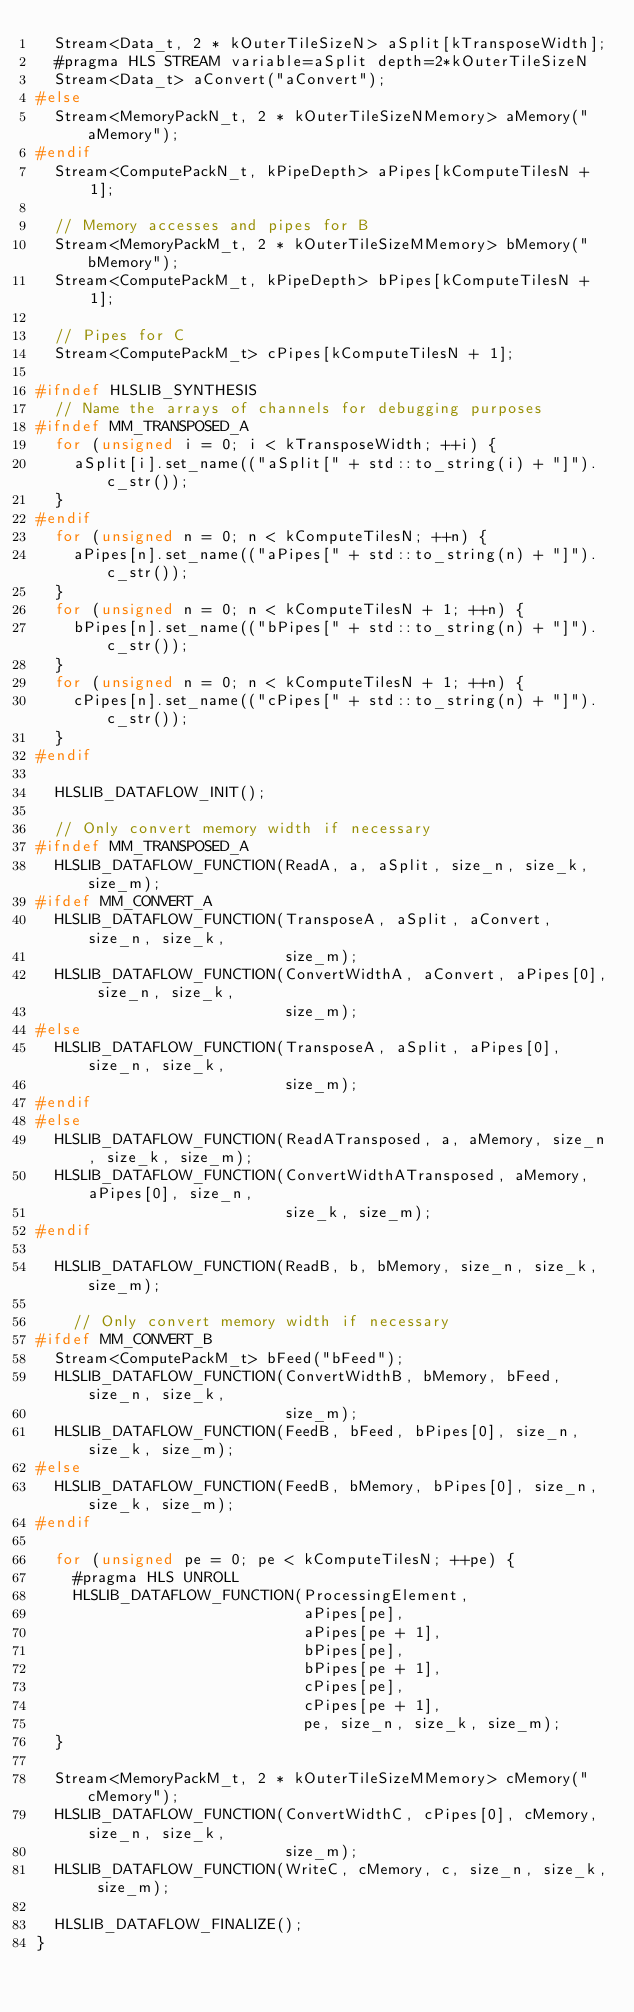Convert code to text. <code><loc_0><loc_0><loc_500><loc_500><_C++_>  Stream<Data_t, 2 * kOuterTileSizeN> aSplit[kTransposeWidth];
  #pragma HLS STREAM variable=aSplit depth=2*kOuterTileSizeN
  Stream<Data_t> aConvert("aConvert");
#else
  Stream<MemoryPackN_t, 2 * kOuterTileSizeNMemory> aMemory("aMemory");
#endif
  Stream<ComputePackN_t, kPipeDepth> aPipes[kComputeTilesN + 1];

  // Memory accesses and pipes for B 
  Stream<MemoryPackM_t, 2 * kOuterTileSizeMMemory> bMemory("bMemory");
  Stream<ComputePackM_t, kPipeDepth> bPipes[kComputeTilesN + 1];

  // Pipes for C
  Stream<ComputePackM_t> cPipes[kComputeTilesN + 1];

#ifndef HLSLIB_SYNTHESIS
  // Name the arrays of channels for debugging purposes
#ifndef MM_TRANSPOSED_A
  for (unsigned i = 0; i < kTransposeWidth; ++i) {
    aSplit[i].set_name(("aSplit[" + std::to_string(i) + "]").c_str());
  }
#endif
  for (unsigned n = 0; n < kComputeTilesN; ++n) {
    aPipes[n].set_name(("aPipes[" + std::to_string(n) + "]").c_str());
  }
  for (unsigned n = 0; n < kComputeTilesN + 1; ++n) {
    bPipes[n].set_name(("bPipes[" + std::to_string(n) + "]").c_str());
  }
  for (unsigned n = 0; n < kComputeTilesN + 1; ++n) {
    cPipes[n].set_name(("cPipes[" + std::to_string(n) + "]").c_str());
  }
#endif

  HLSLIB_DATAFLOW_INIT();

  // Only convert memory width if necessary
#ifndef MM_TRANSPOSED_A
  HLSLIB_DATAFLOW_FUNCTION(ReadA, a, aSplit, size_n, size_k, size_m);
#ifdef MM_CONVERT_A
  HLSLIB_DATAFLOW_FUNCTION(TransposeA, aSplit, aConvert, size_n, size_k,
                           size_m);
  HLSLIB_DATAFLOW_FUNCTION(ConvertWidthA, aConvert, aPipes[0], size_n, size_k,
                           size_m);
#else
  HLSLIB_DATAFLOW_FUNCTION(TransposeA, aSplit, aPipes[0], size_n, size_k,
                           size_m);
#endif
#else
  HLSLIB_DATAFLOW_FUNCTION(ReadATransposed, a, aMemory, size_n, size_k, size_m);
  HLSLIB_DATAFLOW_FUNCTION(ConvertWidthATransposed, aMemory, aPipes[0], size_n,
                           size_k, size_m);
#endif

  HLSLIB_DATAFLOW_FUNCTION(ReadB, b, bMemory, size_n, size_k, size_m);

    // Only convert memory width if necessary
#ifdef MM_CONVERT_B
  Stream<ComputePackM_t> bFeed("bFeed");
  HLSLIB_DATAFLOW_FUNCTION(ConvertWidthB, bMemory, bFeed, size_n, size_k,
                           size_m);
  HLSLIB_DATAFLOW_FUNCTION(FeedB, bFeed, bPipes[0], size_n, size_k, size_m);
#else
  HLSLIB_DATAFLOW_FUNCTION(FeedB, bMemory, bPipes[0], size_n, size_k, size_m);
#endif

  for (unsigned pe = 0; pe < kComputeTilesN; ++pe) {
    #pragma HLS UNROLL
    HLSLIB_DATAFLOW_FUNCTION(ProcessingElement,
                             aPipes[pe],
                             aPipes[pe + 1],
                             bPipes[pe],
                             bPipes[pe + 1],
                             cPipes[pe],
                             cPipes[pe + 1],
                             pe, size_n, size_k, size_m);
  }

  Stream<MemoryPackM_t, 2 * kOuterTileSizeMMemory> cMemory("cMemory");
  HLSLIB_DATAFLOW_FUNCTION(ConvertWidthC, cPipes[0], cMemory, size_n, size_k,
                           size_m);
  HLSLIB_DATAFLOW_FUNCTION(WriteC, cMemory, c, size_n, size_k, size_m);

  HLSLIB_DATAFLOW_FINALIZE();
}
</code> 